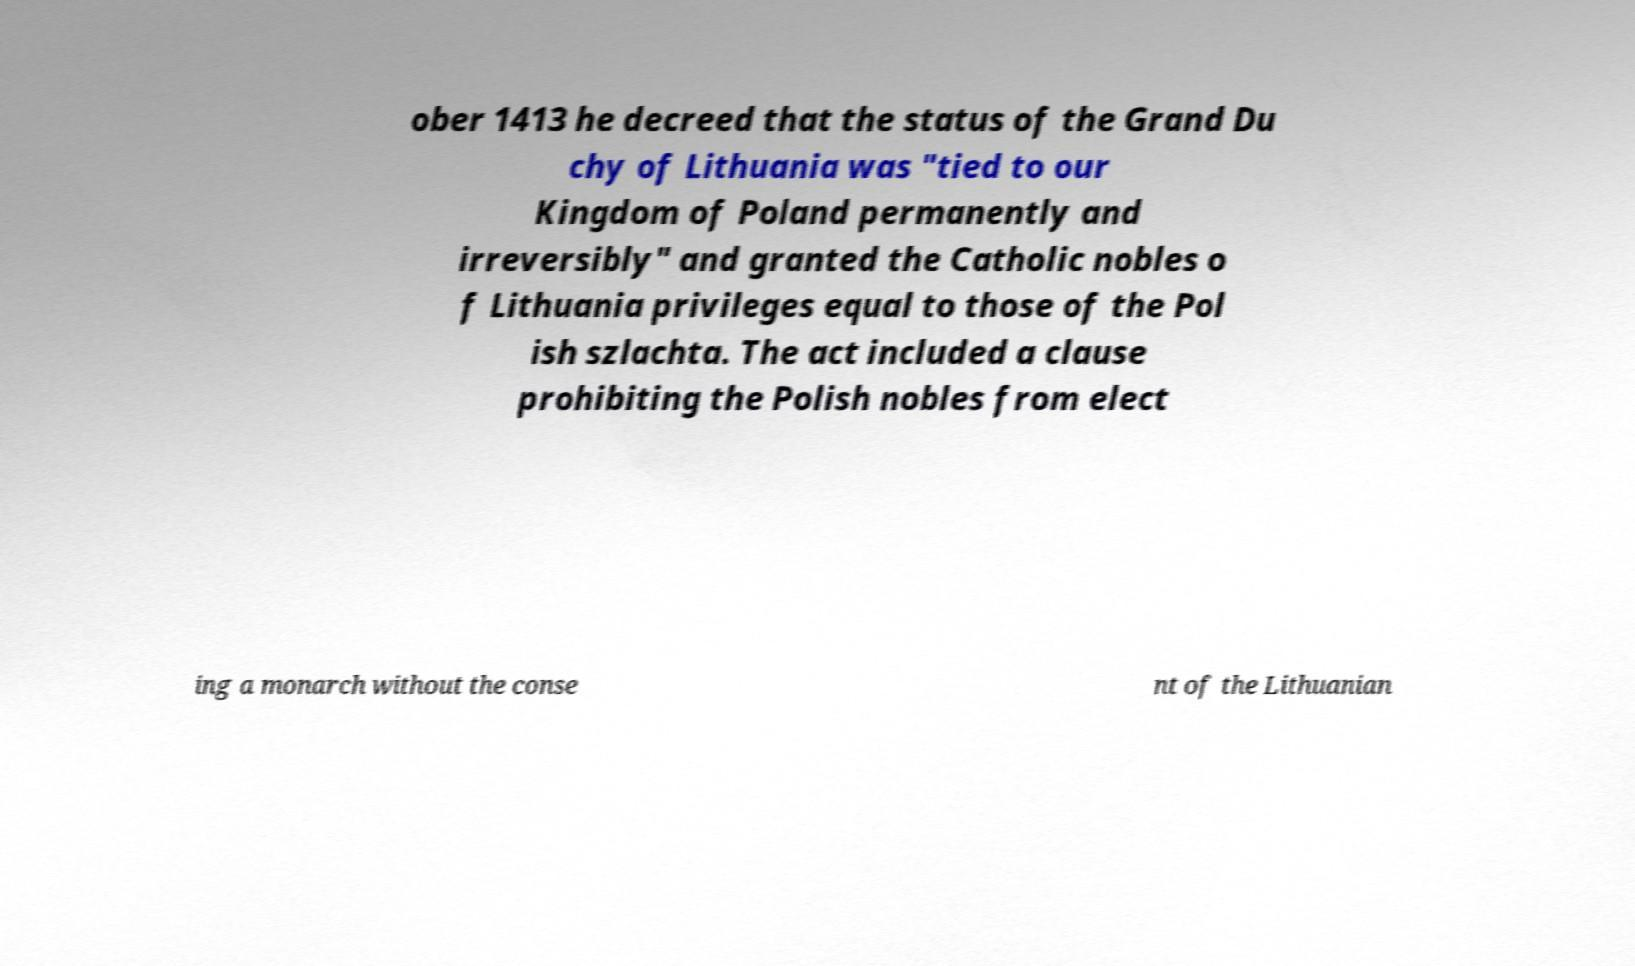Please read and relay the text visible in this image. What does it say? ober 1413 he decreed that the status of the Grand Du chy of Lithuania was "tied to our Kingdom of Poland permanently and irreversibly" and granted the Catholic nobles o f Lithuania privileges equal to those of the Pol ish szlachta. The act included a clause prohibiting the Polish nobles from elect ing a monarch without the conse nt of the Lithuanian 